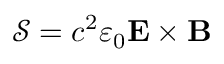<formula> <loc_0><loc_0><loc_500><loc_500>{ \mathcal { S } } = c ^ { 2 } \varepsilon _ { 0 } E \times B</formula> 